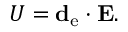<formula> <loc_0><loc_0><loc_500><loc_500>U = d _ { e } \cdot E .</formula> 